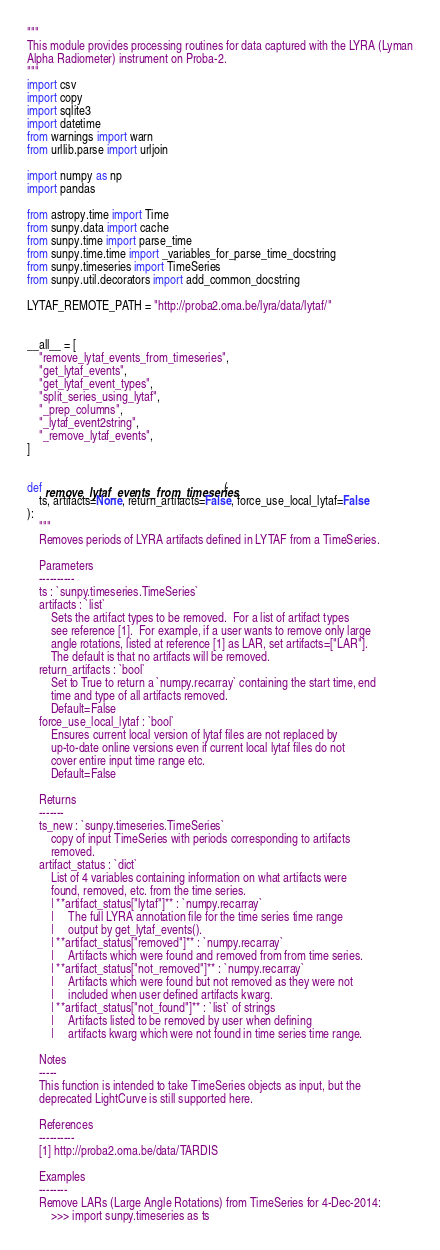Convert code to text. <code><loc_0><loc_0><loc_500><loc_500><_Python_>"""
This module provides processing routines for data captured with the LYRA (Lyman
Alpha Radiometer) instrument on Proba-2.
"""
import csv
import copy
import sqlite3
import datetime
from warnings import warn
from urllib.parse import urljoin

import numpy as np
import pandas

from astropy.time import Time
from sunpy.data import cache
from sunpy.time import parse_time
from sunpy.time.time import _variables_for_parse_time_docstring
from sunpy.timeseries import TimeSeries
from sunpy.util.decorators import add_common_docstring

LYTAF_REMOTE_PATH = "http://proba2.oma.be/lyra/data/lytaf/"


__all__ = [
    "remove_lytaf_events_from_timeseries",
    "get_lytaf_events",
    "get_lytaf_event_types",
    "split_series_using_lytaf",
    "_prep_columns",
    "_lytaf_event2string",
    "_remove_lytaf_events",
]


def remove_lytaf_events_from_timeseries(
    ts, artifacts=None, return_artifacts=False, force_use_local_lytaf=False
):
    """
    Removes periods of LYRA artifacts defined in LYTAF from a TimeSeries.

    Parameters
    ----------
    ts : `sunpy.timeseries.TimeSeries`
    artifacts : `list`
        Sets the artifact types to be removed.  For a list of artifact types
        see reference [1].  For example, if a user wants to remove only large
        angle rotations, listed at reference [1] as LAR, set artifacts=["LAR"].
        The default is that no artifacts will be removed.
    return_artifacts : `bool`
        Set to True to return a `numpy.recarray` containing the start time, end
        time and type of all artifacts removed.
        Default=False
    force_use_local_lytaf : `bool`
        Ensures current local version of lytaf files are not replaced by
        up-to-date online versions even if current local lytaf files do not
        cover entire input time range etc.
        Default=False

    Returns
    -------
    ts_new : `sunpy.timeseries.TimeSeries`
        copy of input TimeSeries with periods corresponding to artifacts
        removed.
    artifact_status : `dict`
        List of 4 variables containing information on what artifacts were
        found, removed, etc. from the time series.
        | **artifact_status["lytaf"]** : `numpy.recarray`
        |     The full LYRA annotation file for the time series time range
        |     output by get_lytaf_events().
        | **artifact_status["removed"]** : `numpy.recarray`
        |     Artifacts which were found and removed from from time series.
        | **artifact_status["not_removed"]** : `numpy.recarray`
        |     Artifacts which were found but not removed as they were not
        |     included when user defined artifacts kwarg.
        | **artifact_status["not_found"]** : `list` of strings
        |     Artifacts listed to be removed by user when defining
        |     artifacts kwarg which were not found in time series time range.

    Notes
    -----
    This function is intended to take TimeSeries objects as input, but the
    deprecated LightCurve is still supported here.

    References
    ----------
    [1] http://proba2.oma.be/data/TARDIS

    Examples
    --------
    Remove LARs (Large Angle Rotations) from TimeSeries for 4-Dec-2014:
        >>> import sunpy.timeseries as ts</code> 